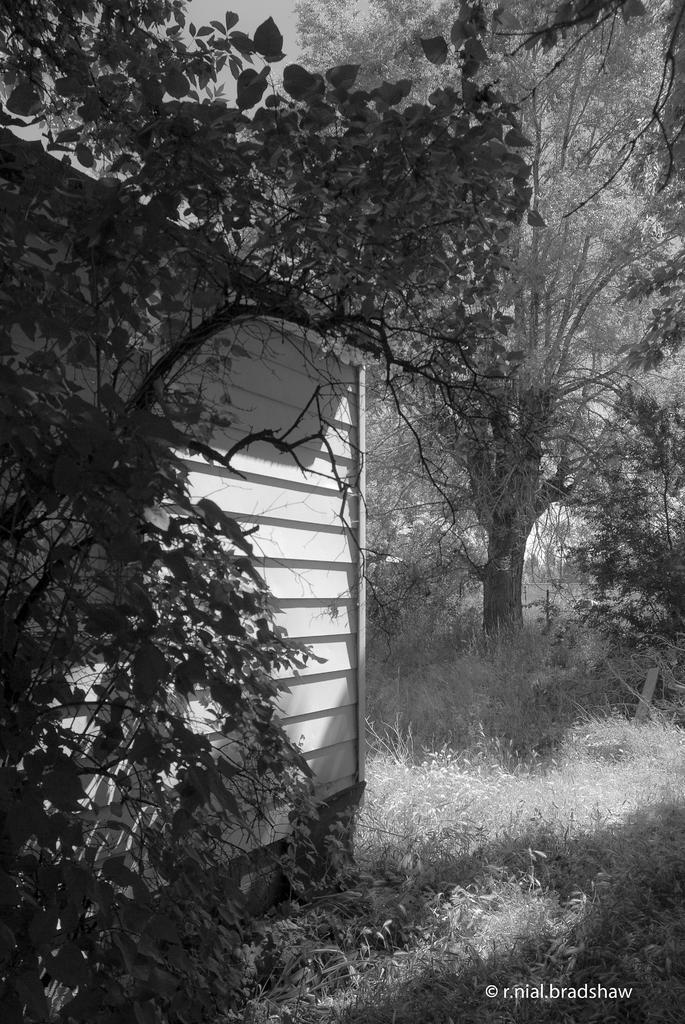Can you describe this image briefly? This is a black and white picture. In this picture we can see some grass on the ground. We can see a watermark in the bottom right. There is a house and a plant on the left side. We can see a few trees in the background. 